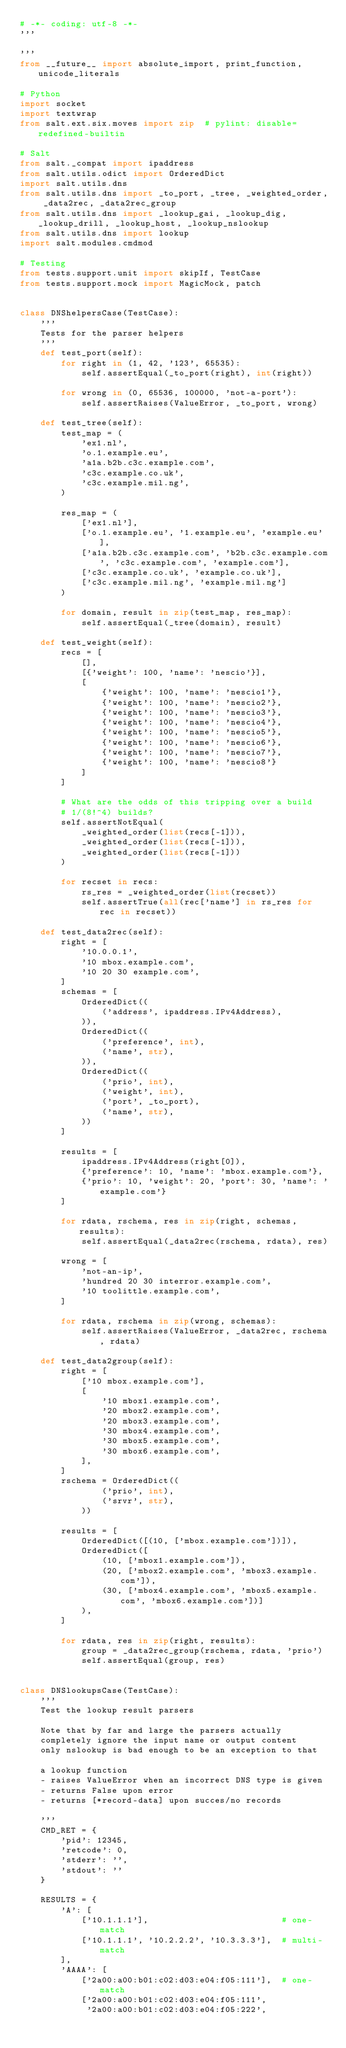<code> <loc_0><loc_0><loc_500><loc_500><_Python_># -*- coding: utf-8 -*-
'''

'''
from __future__ import absolute_import, print_function, unicode_literals

# Python
import socket
import textwrap
from salt.ext.six.moves import zip  # pylint: disable=redefined-builtin

# Salt
from salt._compat import ipaddress
from salt.utils.odict import OrderedDict
import salt.utils.dns
from salt.utils.dns import _to_port, _tree, _weighted_order, _data2rec, _data2rec_group
from salt.utils.dns import _lookup_gai, _lookup_dig, _lookup_drill, _lookup_host, _lookup_nslookup
from salt.utils.dns import lookup
import salt.modules.cmdmod

# Testing
from tests.support.unit import skipIf, TestCase
from tests.support.mock import MagicMock, patch


class DNShelpersCase(TestCase):
    '''
    Tests for the parser helpers
    '''
    def test_port(self):
        for right in (1, 42, '123', 65535):
            self.assertEqual(_to_port(right), int(right))

        for wrong in (0, 65536, 100000, 'not-a-port'):
            self.assertRaises(ValueError, _to_port, wrong)

    def test_tree(self):
        test_map = (
            'ex1.nl',
            'o.1.example.eu',
            'a1a.b2b.c3c.example.com',
            'c3c.example.co.uk',
            'c3c.example.mil.ng',
        )

        res_map = (
            ['ex1.nl'],
            ['o.1.example.eu', '1.example.eu', 'example.eu'],
            ['a1a.b2b.c3c.example.com', 'b2b.c3c.example.com', 'c3c.example.com', 'example.com'],
            ['c3c.example.co.uk', 'example.co.uk'],
            ['c3c.example.mil.ng', 'example.mil.ng']
        )

        for domain, result in zip(test_map, res_map):
            self.assertEqual(_tree(domain), result)

    def test_weight(self):
        recs = [
            [],
            [{'weight': 100, 'name': 'nescio'}],
            [
                {'weight': 100, 'name': 'nescio1'},
                {'weight': 100, 'name': 'nescio2'},
                {'weight': 100, 'name': 'nescio3'},
                {'weight': 100, 'name': 'nescio4'},
                {'weight': 100, 'name': 'nescio5'},
                {'weight': 100, 'name': 'nescio6'},
                {'weight': 100, 'name': 'nescio7'},
                {'weight': 100, 'name': 'nescio8'}
            ]
        ]

        # What are the odds of this tripping over a build
        # 1/(8!^4) builds?
        self.assertNotEqual(
            _weighted_order(list(recs[-1])),
            _weighted_order(list(recs[-1])),
            _weighted_order(list(recs[-1]))
        )

        for recset in recs:
            rs_res = _weighted_order(list(recset))
            self.assertTrue(all(rec['name'] in rs_res for rec in recset))

    def test_data2rec(self):
        right = [
            '10.0.0.1',
            '10 mbox.example.com',
            '10 20 30 example.com',
        ]
        schemas = [
            OrderedDict((
                ('address', ipaddress.IPv4Address),
            )),
            OrderedDict((
                ('preference', int),
                ('name', str),
            )),
            OrderedDict((
                ('prio', int),
                ('weight', int),
                ('port', _to_port),
                ('name', str),
            ))
        ]

        results = [
            ipaddress.IPv4Address(right[0]),
            {'preference': 10, 'name': 'mbox.example.com'},
            {'prio': 10, 'weight': 20, 'port': 30, 'name': 'example.com'}
        ]

        for rdata, rschema, res in zip(right, schemas, results):
            self.assertEqual(_data2rec(rschema, rdata), res)

        wrong = [
            'not-an-ip',
            'hundred 20 30 interror.example.com',
            '10 toolittle.example.com',
        ]

        for rdata, rschema in zip(wrong, schemas):
            self.assertRaises(ValueError, _data2rec, rschema, rdata)

    def test_data2group(self):
        right = [
            ['10 mbox.example.com'],
            [
                '10 mbox1.example.com',
                '20 mbox2.example.com',
                '20 mbox3.example.com',
                '30 mbox4.example.com',
                '30 mbox5.example.com',
                '30 mbox6.example.com',
            ],
        ]
        rschema = OrderedDict((
                ('prio', int),
                ('srvr', str),
            ))

        results = [
            OrderedDict([(10, ['mbox.example.com'])]),
            OrderedDict([
                (10, ['mbox1.example.com']),
                (20, ['mbox2.example.com', 'mbox3.example.com']),
                (30, ['mbox4.example.com', 'mbox5.example.com', 'mbox6.example.com'])]
            ),
        ]

        for rdata, res in zip(right, results):
            group = _data2rec_group(rschema, rdata, 'prio')
            self.assertEqual(group, res)


class DNSlookupsCase(TestCase):
    '''
    Test the lookup result parsers

    Note that by far and large the parsers actually
    completely ignore the input name or output content
    only nslookup is bad enough to be an exception to that

    a lookup function
    - raises ValueError when an incorrect DNS type is given
    - returns False upon error
    - returns [*record-data] upon succes/no records

    '''
    CMD_RET = {
        'pid': 12345,
        'retcode': 0,
        'stderr': '',
        'stdout': ''
    }

    RESULTS = {
        'A': [
            ['10.1.1.1'],                          # one-match
            ['10.1.1.1', '10.2.2.2', '10.3.3.3'],  # multi-match
        ],
        'AAAA': [
            ['2a00:a00:b01:c02:d03:e04:f05:111'],  # one-match
            ['2a00:a00:b01:c02:d03:e04:f05:111',
             '2a00:a00:b01:c02:d03:e04:f05:222',</code> 